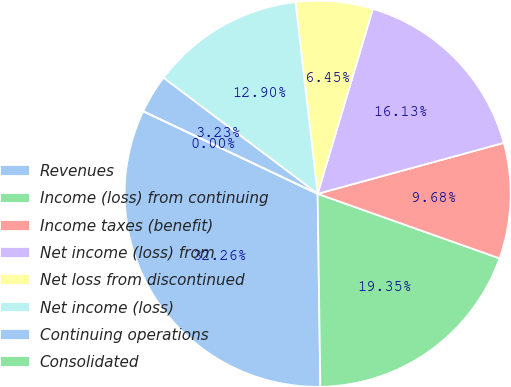Convert chart. <chart><loc_0><loc_0><loc_500><loc_500><pie_chart><fcel>Revenues<fcel>Income (loss) from continuing<fcel>Income taxes (benefit)<fcel>Net income (loss) from<fcel>Net loss from discontinued<fcel>Net income (loss)<fcel>Continuing operations<fcel>Consolidated<nl><fcel>32.26%<fcel>19.35%<fcel>9.68%<fcel>16.13%<fcel>6.45%<fcel>12.9%<fcel>3.23%<fcel>0.0%<nl></chart> 